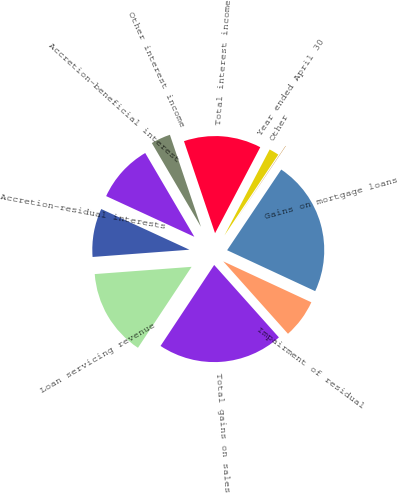Convert chart. <chart><loc_0><loc_0><loc_500><loc_500><pie_chart><fcel>Year ended April 30<fcel>Gains on mortgage loans<fcel>Impairment of residual<fcel>Total gains on sales<fcel>Loan servicing revenue<fcel>Accretion-residual interests<fcel>Accretion-beneficial interest<fcel>Other interest income<fcel>Total interest income<fcel>Other<nl><fcel>0.05%<fcel>22.52%<fcel>6.47%<fcel>20.92%<fcel>14.5%<fcel>8.07%<fcel>9.68%<fcel>3.26%<fcel>12.89%<fcel>1.65%<nl></chart> 